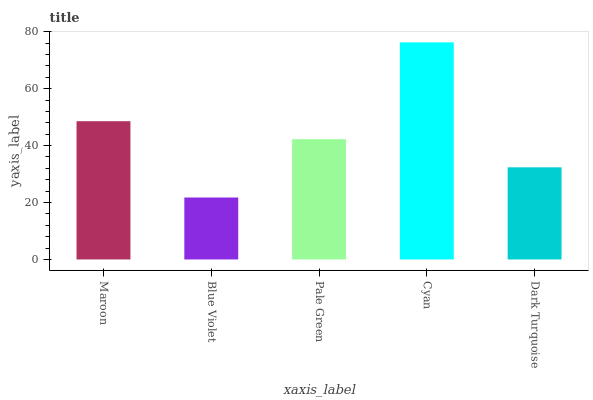Is Blue Violet the minimum?
Answer yes or no. Yes. Is Cyan the maximum?
Answer yes or no. Yes. Is Pale Green the minimum?
Answer yes or no. No. Is Pale Green the maximum?
Answer yes or no. No. Is Pale Green greater than Blue Violet?
Answer yes or no. Yes. Is Blue Violet less than Pale Green?
Answer yes or no. Yes. Is Blue Violet greater than Pale Green?
Answer yes or no. No. Is Pale Green less than Blue Violet?
Answer yes or no. No. Is Pale Green the high median?
Answer yes or no. Yes. Is Pale Green the low median?
Answer yes or no. Yes. Is Maroon the high median?
Answer yes or no. No. Is Cyan the low median?
Answer yes or no. No. 